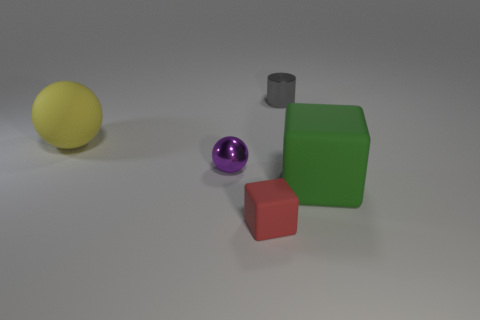Add 1 rubber balls. How many objects exist? 6 Subtract all balls. How many objects are left? 3 Add 3 big purple metallic things. How many big purple metallic things exist? 3 Subtract 1 green blocks. How many objects are left? 4 Subtract all small red things. Subtract all purple cylinders. How many objects are left? 4 Add 4 purple things. How many purple things are left? 5 